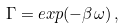Convert formula to latex. <formula><loc_0><loc_0><loc_500><loc_500>\Gamma = e x p ( - \beta \omega ) \, ,</formula> 